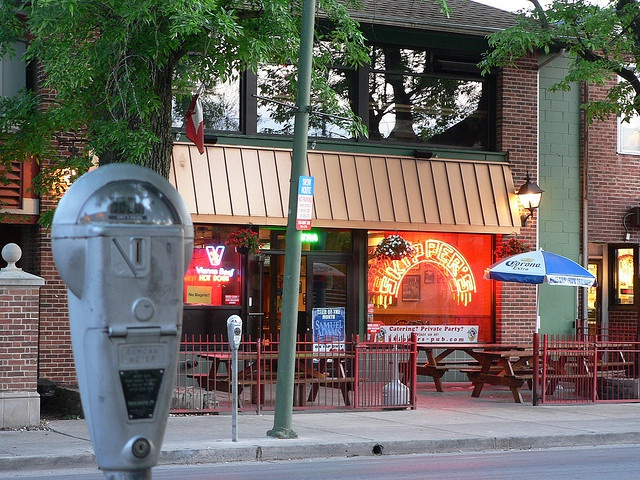Describe the objects in this image and their specific colors. I can see parking meter in darkgreen, gray, and lightblue tones, bench in darkgreen, black, maroon, brown, and gray tones, umbrella in darkgreen, lightblue, and blue tones, bench in darkgreen, black, gray, maroon, and brown tones, and dining table in darkgreen, black, brown, maroon, and gray tones in this image. 